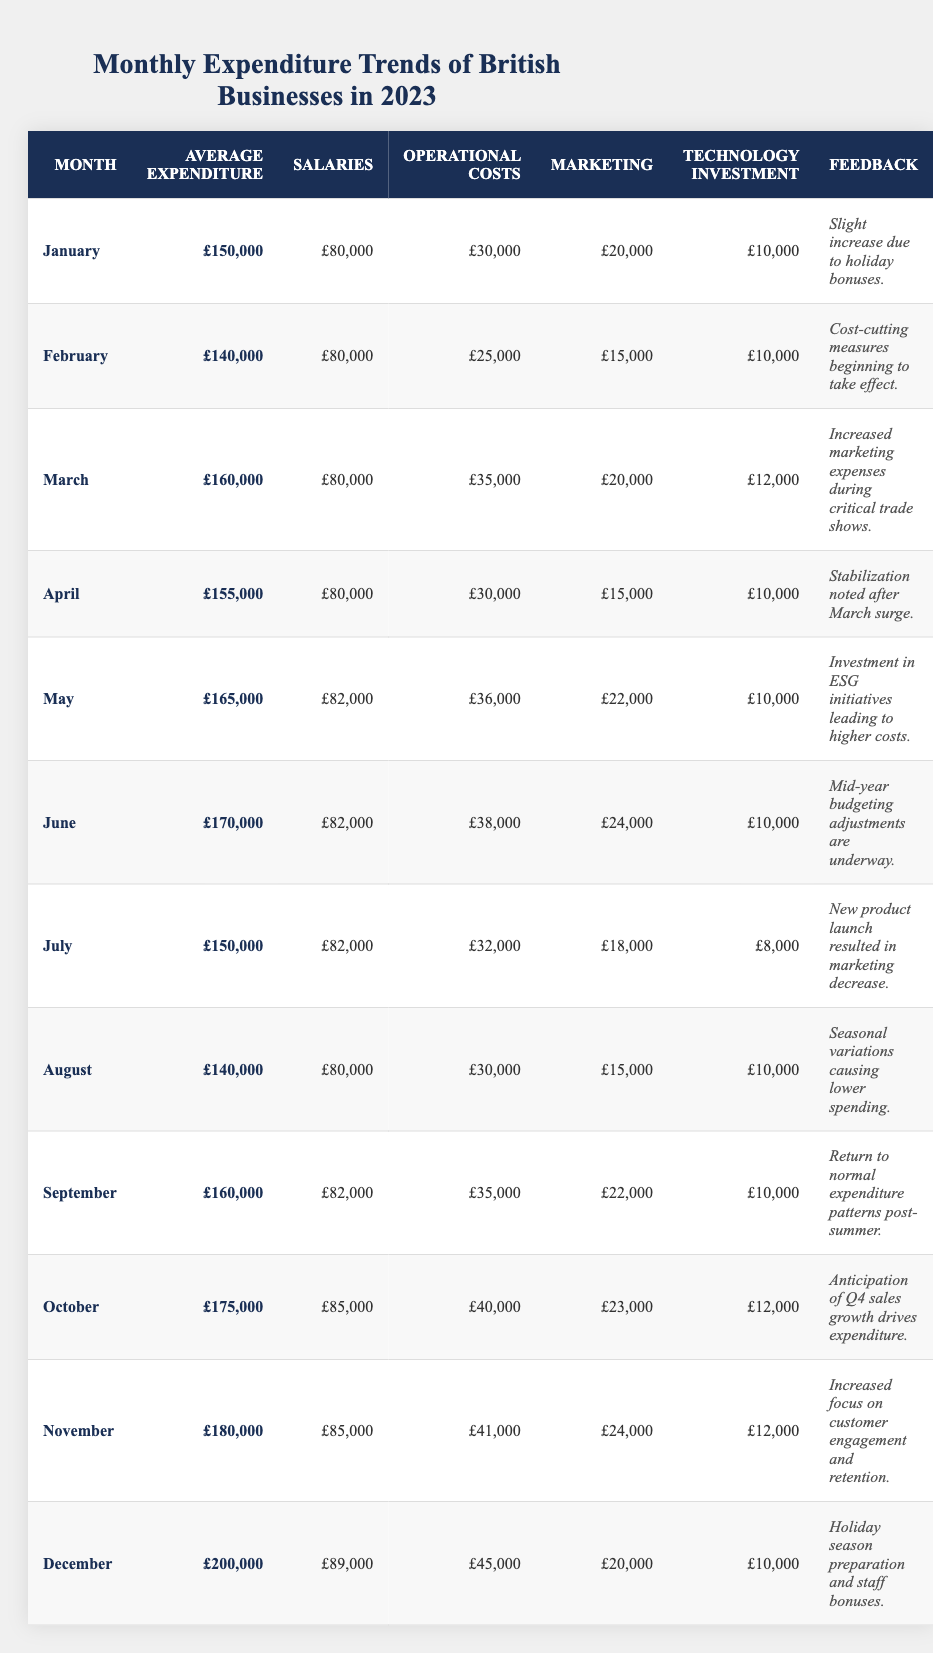What was the average expenditure in March? According to the table, the average expenditure for March is explicitly listed as £160,000.
Answer: £160,000 In which month did marketing expenses reach their highest? By examining the marketing column, the highest value is £24,000 in June.
Answer: June What is the total average expenditure from January to April? Adding the average expenditures for the four months: £150,000 + £140,000 + £160,000 + £155,000 gives a total of £605,000. Dividing this by 4 months results in an average of £151,250.
Answer: £151,250 Did expenditures increase from October to November? The average expenditure in October is £175,000 and in November it is £180,000, indicating an increase.
Answer: Yes Which month had the lowest operational costs and what was the amount? The month with the lowest operational costs is February at £25,000.
Answer: February, £25,000 What is the difference in average expenditure between December and January? December's average expenditure is £200,000 and January's is £150,000. The difference is £200,000 - £150,000 = £50,000.
Answer: £50,000 How much did marketing expenditures decrease between March and April? In March, marketing expenses were £20,000, and in April they decreased to £15,000, a difference of £5,000.
Answer: £5,000 Is the feedback for June related to cost-cutting measures? No, the feedback for June discusses mid-year budgeting adjustments, which are not necessarily related to cost-cutting.
Answer: No What was the highest salary expenditure month and what was the amount? The month with the highest salary expenditure is December, where salaries reached £89,000.
Answer: December, £89,000 What was the average expenditure for the second half of the year (July to December)? The average for the second half of the year is calculated by summing the average expenditures from July (£150,000) to December (£200,000) which totals £1,085,000; dividing by 6 months gives an average of £180,833.
Answer: £180,833 